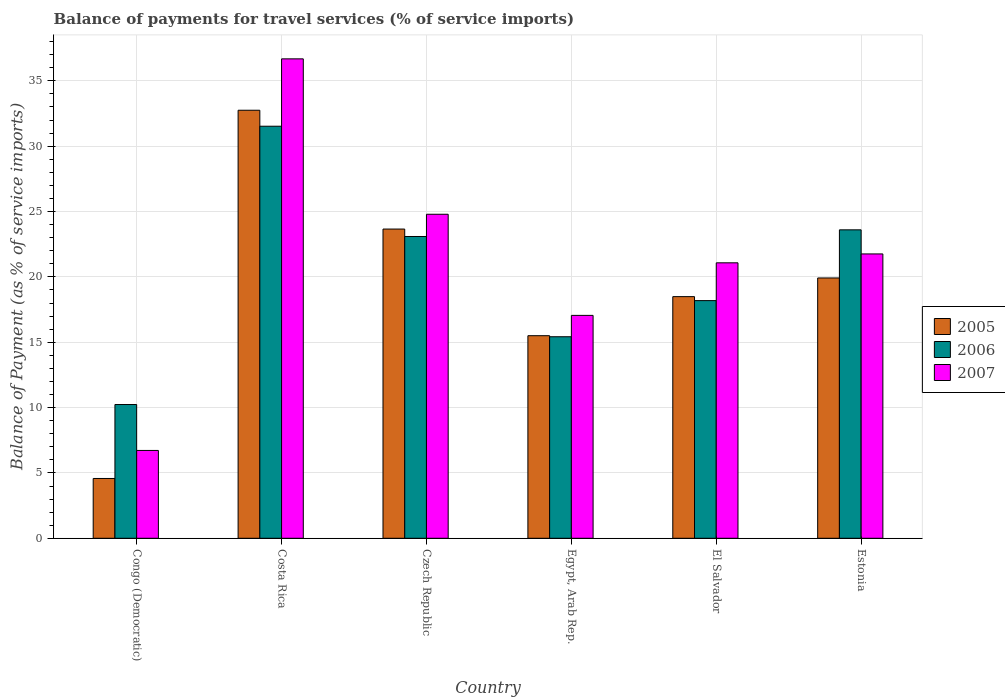How many different coloured bars are there?
Ensure brevity in your answer.  3. Are the number of bars on each tick of the X-axis equal?
Your answer should be compact. Yes. What is the label of the 6th group of bars from the left?
Give a very brief answer. Estonia. What is the balance of payments for travel services in 2005 in Costa Rica?
Provide a short and direct response. 32.75. Across all countries, what is the maximum balance of payments for travel services in 2006?
Keep it short and to the point. 31.53. Across all countries, what is the minimum balance of payments for travel services in 2006?
Make the answer very short. 10.23. In which country was the balance of payments for travel services in 2005 minimum?
Make the answer very short. Congo (Democratic). What is the total balance of payments for travel services in 2007 in the graph?
Provide a succinct answer. 128.08. What is the difference between the balance of payments for travel services in 2007 in Czech Republic and that in Estonia?
Ensure brevity in your answer.  3.03. What is the difference between the balance of payments for travel services in 2007 in Czech Republic and the balance of payments for travel services in 2005 in Estonia?
Your answer should be compact. 4.87. What is the average balance of payments for travel services in 2007 per country?
Offer a very short reply. 21.35. What is the difference between the balance of payments for travel services of/in 2005 and balance of payments for travel services of/in 2007 in El Salvador?
Give a very brief answer. -2.59. In how many countries, is the balance of payments for travel services in 2006 greater than 26 %?
Your answer should be very brief. 1. What is the ratio of the balance of payments for travel services in 2005 in Czech Republic to that in Egypt, Arab Rep.?
Your answer should be very brief. 1.53. Is the balance of payments for travel services in 2006 in Czech Republic less than that in El Salvador?
Your answer should be very brief. No. Is the difference between the balance of payments for travel services in 2005 in Czech Republic and Estonia greater than the difference between the balance of payments for travel services in 2007 in Czech Republic and Estonia?
Provide a short and direct response. Yes. What is the difference between the highest and the second highest balance of payments for travel services in 2006?
Offer a terse response. 0.51. What is the difference between the highest and the lowest balance of payments for travel services in 2006?
Offer a very short reply. 21.29. In how many countries, is the balance of payments for travel services in 2006 greater than the average balance of payments for travel services in 2006 taken over all countries?
Offer a very short reply. 3. Is the sum of the balance of payments for travel services in 2006 in El Salvador and Estonia greater than the maximum balance of payments for travel services in 2007 across all countries?
Your response must be concise. Yes. Is it the case that in every country, the sum of the balance of payments for travel services in 2006 and balance of payments for travel services in 2005 is greater than the balance of payments for travel services in 2007?
Give a very brief answer. Yes. How many bars are there?
Make the answer very short. 18. Are the values on the major ticks of Y-axis written in scientific E-notation?
Offer a terse response. No. Where does the legend appear in the graph?
Your response must be concise. Center right. What is the title of the graph?
Your response must be concise. Balance of payments for travel services (% of service imports). Does "1980" appear as one of the legend labels in the graph?
Provide a short and direct response. No. What is the label or title of the Y-axis?
Keep it short and to the point. Balance of Payment (as % of service imports). What is the Balance of Payment (as % of service imports) in 2005 in Congo (Democratic)?
Provide a succinct answer. 4.58. What is the Balance of Payment (as % of service imports) in 2006 in Congo (Democratic)?
Keep it short and to the point. 10.23. What is the Balance of Payment (as % of service imports) in 2007 in Congo (Democratic)?
Ensure brevity in your answer.  6.72. What is the Balance of Payment (as % of service imports) in 2005 in Costa Rica?
Provide a short and direct response. 32.75. What is the Balance of Payment (as % of service imports) of 2006 in Costa Rica?
Make the answer very short. 31.53. What is the Balance of Payment (as % of service imports) of 2007 in Costa Rica?
Your response must be concise. 36.68. What is the Balance of Payment (as % of service imports) of 2005 in Czech Republic?
Keep it short and to the point. 23.66. What is the Balance of Payment (as % of service imports) of 2006 in Czech Republic?
Keep it short and to the point. 23.09. What is the Balance of Payment (as % of service imports) in 2007 in Czech Republic?
Give a very brief answer. 24.79. What is the Balance of Payment (as % of service imports) of 2005 in Egypt, Arab Rep.?
Offer a very short reply. 15.5. What is the Balance of Payment (as % of service imports) of 2006 in Egypt, Arab Rep.?
Your response must be concise. 15.42. What is the Balance of Payment (as % of service imports) in 2007 in Egypt, Arab Rep.?
Ensure brevity in your answer.  17.05. What is the Balance of Payment (as % of service imports) in 2005 in El Salvador?
Offer a very short reply. 18.49. What is the Balance of Payment (as % of service imports) of 2006 in El Salvador?
Ensure brevity in your answer.  18.18. What is the Balance of Payment (as % of service imports) in 2007 in El Salvador?
Offer a very short reply. 21.08. What is the Balance of Payment (as % of service imports) in 2005 in Estonia?
Your answer should be compact. 19.92. What is the Balance of Payment (as % of service imports) in 2006 in Estonia?
Your response must be concise. 23.6. What is the Balance of Payment (as % of service imports) in 2007 in Estonia?
Keep it short and to the point. 21.76. Across all countries, what is the maximum Balance of Payment (as % of service imports) in 2005?
Make the answer very short. 32.75. Across all countries, what is the maximum Balance of Payment (as % of service imports) of 2006?
Ensure brevity in your answer.  31.53. Across all countries, what is the maximum Balance of Payment (as % of service imports) of 2007?
Provide a succinct answer. 36.68. Across all countries, what is the minimum Balance of Payment (as % of service imports) in 2005?
Make the answer very short. 4.58. Across all countries, what is the minimum Balance of Payment (as % of service imports) of 2006?
Provide a succinct answer. 10.23. Across all countries, what is the minimum Balance of Payment (as % of service imports) in 2007?
Offer a terse response. 6.72. What is the total Balance of Payment (as % of service imports) in 2005 in the graph?
Your response must be concise. 114.89. What is the total Balance of Payment (as % of service imports) of 2006 in the graph?
Make the answer very short. 122.05. What is the total Balance of Payment (as % of service imports) of 2007 in the graph?
Provide a short and direct response. 128.08. What is the difference between the Balance of Payment (as % of service imports) in 2005 in Congo (Democratic) and that in Costa Rica?
Your response must be concise. -28.17. What is the difference between the Balance of Payment (as % of service imports) of 2006 in Congo (Democratic) and that in Costa Rica?
Offer a terse response. -21.29. What is the difference between the Balance of Payment (as % of service imports) of 2007 in Congo (Democratic) and that in Costa Rica?
Provide a succinct answer. -29.96. What is the difference between the Balance of Payment (as % of service imports) in 2005 in Congo (Democratic) and that in Czech Republic?
Provide a short and direct response. -19.08. What is the difference between the Balance of Payment (as % of service imports) in 2006 in Congo (Democratic) and that in Czech Republic?
Offer a very short reply. -12.86. What is the difference between the Balance of Payment (as % of service imports) of 2007 in Congo (Democratic) and that in Czech Republic?
Provide a succinct answer. -18.07. What is the difference between the Balance of Payment (as % of service imports) of 2005 in Congo (Democratic) and that in Egypt, Arab Rep.?
Provide a short and direct response. -10.92. What is the difference between the Balance of Payment (as % of service imports) in 2006 in Congo (Democratic) and that in Egypt, Arab Rep.?
Give a very brief answer. -5.19. What is the difference between the Balance of Payment (as % of service imports) of 2007 in Congo (Democratic) and that in Egypt, Arab Rep.?
Make the answer very short. -10.33. What is the difference between the Balance of Payment (as % of service imports) in 2005 in Congo (Democratic) and that in El Salvador?
Provide a succinct answer. -13.91. What is the difference between the Balance of Payment (as % of service imports) of 2006 in Congo (Democratic) and that in El Salvador?
Your response must be concise. -7.95. What is the difference between the Balance of Payment (as % of service imports) in 2007 in Congo (Democratic) and that in El Salvador?
Your response must be concise. -14.36. What is the difference between the Balance of Payment (as % of service imports) in 2005 in Congo (Democratic) and that in Estonia?
Offer a very short reply. -15.34. What is the difference between the Balance of Payment (as % of service imports) of 2006 in Congo (Democratic) and that in Estonia?
Offer a very short reply. -13.37. What is the difference between the Balance of Payment (as % of service imports) in 2007 in Congo (Democratic) and that in Estonia?
Give a very brief answer. -15.04. What is the difference between the Balance of Payment (as % of service imports) of 2005 in Costa Rica and that in Czech Republic?
Your response must be concise. 9.09. What is the difference between the Balance of Payment (as % of service imports) of 2006 in Costa Rica and that in Czech Republic?
Your answer should be compact. 8.44. What is the difference between the Balance of Payment (as % of service imports) in 2007 in Costa Rica and that in Czech Republic?
Give a very brief answer. 11.89. What is the difference between the Balance of Payment (as % of service imports) of 2005 in Costa Rica and that in Egypt, Arab Rep.?
Ensure brevity in your answer.  17.25. What is the difference between the Balance of Payment (as % of service imports) of 2006 in Costa Rica and that in Egypt, Arab Rep.?
Give a very brief answer. 16.11. What is the difference between the Balance of Payment (as % of service imports) in 2007 in Costa Rica and that in Egypt, Arab Rep.?
Your response must be concise. 19.63. What is the difference between the Balance of Payment (as % of service imports) of 2005 in Costa Rica and that in El Salvador?
Offer a terse response. 14.26. What is the difference between the Balance of Payment (as % of service imports) of 2006 in Costa Rica and that in El Salvador?
Offer a very short reply. 13.34. What is the difference between the Balance of Payment (as % of service imports) of 2007 in Costa Rica and that in El Salvador?
Your answer should be compact. 15.61. What is the difference between the Balance of Payment (as % of service imports) of 2005 in Costa Rica and that in Estonia?
Keep it short and to the point. 12.83. What is the difference between the Balance of Payment (as % of service imports) of 2006 in Costa Rica and that in Estonia?
Keep it short and to the point. 7.93. What is the difference between the Balance of Payment (as % of service imports) in 2007 in Costa Rica and that in Estonia?
Offer a very short reply. 14.93. What is the difference between the Balance of Payment (as % of service imports) of 2005 in Czech Republic and that in Egypt, Arab Rep.?
Ensure brevity in your answer.  8.16. What is the difference between the Balance of Payment (as % of service imports) of 2006 in Czech Republic and that in Egypt, Arab Rep.?
Your answer should be compact. 7.67. What is the difference between the Balance of Payment (as % of service imports) in 2007 in Czech Republic and that in Egypt, Arab Rep.?
Offer a terse response. 7.74. What is the difference between the Balance of Payment (as % of service imports) of 2005 in Czech Republic and that in El Salvador?
Your response must be concise. 5.17. What is the difference between the Balance of Payment (as % of service imports) in 2006 in Czech Republic and that in El Salvador?
Make the answer very short. 4.91. What is the difference between the Balance of Payment (as % of service imports) in 2007 in Czech Republic and that in El Salvador?
Your answer should be very brief. 3.72. What is the difference between the Balance of Payment (as % of service imports) of 2005 in Czech Republic and that in Estonia?
Offer a terse response. 3.74. What is the difference between the Balance of Payment (as % of service imports) of 2006 in Czech Republic and that in Estonia?
Make the answer very short. -0.51. What is the difference between the Balance of Payment (as % of service imports) in 2007 in Czech Republic and that in Estonia?
Your response must be concise. 3.04. What is the difference between the Balance of Payment (as % of service imports) of 2005 in Egypt, Arab Rep. and that in El Salvador?
Provide a short and direct response. -2.99. What is the difference between the Balance of Payment (as % of service imports) in 2006 in Egypt, Arab Rep. and that in El Salvador?
Your response must be concise. -2.76. What is the difference between the Balance of Payment (as % of service imports) in 2007 in Egypt, Arab Rep. and that in El Salvador?
Make the answer very short. -4.02. What is the difference between the Balance of Payment (as % of service imports) in 2005 in Egypt, Arab Rep. and that in Estonia?
Provide a succinct answer. -4.42. What is the difference between the Balance of Payment (as % of service imports) in 2006 in Egypt, Arab Rep. and that in Estonia?
Your answer should be compact. -8.18. What is the difference between the Balance of Payment (as % of service imports) of 2007 in Egypt, Arab Rep. and that in Estonia?
Offer a terse response. -4.7. What is the difference between the Balance of Payment (as % of service imports) of 2005 in El Salvador and that in Estonia?
Your response must be concise. -1.43. What is the difference between the Balance of Payment (as % of service imports) in 2006 in El Salvador and that in Estonia?
Make the answer very short. -5.42. What is the difference between the Balance of Payment (as % of service imports) of 2007 in El Salvador and that in Estonia?
Your answer should be very brief. -0.68. What is the difference between the Balance of Payment (as % of service imports) in 2005 in Congo (Democratic) and the Balance of Payment (as % of service imports) in 2006 in Costa Rica?
Your response must be concise. -26.95. What is the difference between the Balance of Payment (as % of service imports) of 2005 in Congo (Democratic) and the Balance of Payment (as % of service imports) of 2007 in Costa Rica?
Ensure brevity in your answer.  -32.11. What is the difference between the Balance of Payment (as % of service imports) of 2006 in Congo (Democratic) and the Balance of Payment (as % of service imports) of 2007 in Costa Rica?
Provide a short and direct response. -26.45. What is the difference between the Balance of Payment (as % of service imports) in 2005 in Congo (Democratic) and the Balance of Payment (as % of service imports) in 2006 in Czech Republic?
Make the answer very short. -18.51. What is the difference between the Balance of Payment (as % of service imports) of 2005 in Congo (Democratic) and the Balance of Payment (as % of service imports) of 2007 in Czech Republic?
Give a very brief answer. -20.22. What is the difference between the Balance of Payment (as % of service imports) of 2006 in Congo (Democratic) and the Balance of Payment (as % of service imports) of 2007 in Czech Republic?
Keep it short and to the point. -14.56. What is the difference between the Balance of Payment (as % of service imports) of 2005 in Congo (Democratic) and the Balance of Payment (as % of service imports) of 2006 in Egypt, Arab Rep.?
Keep it short and to the point. -10.84. What is the difference between the Balance of Payment (as % of service imports) of 2005 in Congo (Democratic) and the Balance of Payment (as % of service imports) of 2007 in Egypt, Arab Rep.?
Provide a short and direct response. -12.48. What is the difference between the Balance of Payment (as % of service imports) of 2006 in Congo (Democratic) and the Balance of Payment (as % of service imports) of 2007 in Egypt, Arab Rep.?
Offer a very short reply. -6.82. What is the difference between the Balance of Payment (as % of service imports) in 2005 in Congo (Democratic) and the Balance of Payment (as % of service imports) in 2006 in El Salvador?
Offer a terse response. -13.61. What is the difference between the Balance of Payment (as % of service imports) of 2005 in Congo (Democratic) and the Balance of Payment (as % of service imports) of 2007 in El Salvador?
Provide a succinct answer. -16.5. What is the difference between the Balance of Payment (as % of service imports) in 2006 in Congo (Democratic) and the Balance of Payment (as % of service imports) in 2007 in El Salvador?
Provide a succinct answer. -10.84. What is the difference between the Balance of Payment (as % of service imports) of 2005 in Congo (Democratic) and the Balance of Payment (as % of service imports) of 2006 in Estonia?
Provide a succinct answer. -19.02. What is the difference between the Balance of Payment (as % of service imports) of 2005 in Congo (Democratic) and the Balance of Payment (as % of service imports) of 2007 in Estonia?
Make the answer very short. -17.18. What is the difference between the Balance of Payment (as % of service imports) of 2006 in Congo (Democratic) and the Balance of Payment (as % of service imports) of 2007 in Estonia?
Your response must be concise. -11.52. What is the difference between the Balance of Payment (as % of service imports) of 2005 in Costa Rica and the Balance of Payment (as % of service imports) of 2006 in Czech Republic?
Give a very brief answer. 9.66. What is the difference between the Balance of Payment (as % of service imports) in 2005 in Costa Rica and the Balance of Payment (as % of service imports) in 2007 in Czech Republic?
Provide a short and direct response. 7.96. What is the difference between the Balance of Payment (as % of service imports) of 2006 in Costa Rica and the Balance of Payment (as % of service imports) of 2007 in Czech Republic?
Give a very brief answer. 6.74. What is the difference between the Balance of Payment (as % of service imports) of 2005 in Costa Rica and the Balance of Payment (as % of service imports) of 2006 in Egypt, Arab Rep.?
Your answer should be very brief. 17.33. What is the difference between the Balance of Payment (as % of service imports) in 2005 in Costa Rica and the Balance of Payment (as % of service imports) in 2007 in Egypt, Arab Rep.?
Provide a short and direct response. 15.7. What is the difference between the Balance of Payment (as % of service imports) in 2006 in Costa Rica and the Balance of Payment (as % of service imports) in 2007 in Egypt, Arab Rep.?
Provide a short and direct response. 14.47. What is the difference between the Balance of Payment (as % of service imports) of 2005 in Costa Rica and the Balance of Payment (as % of service imports) of 2006 in El Salvador?
Your answer should be compact. 14.57. What is the difference between the Balance of Payment (as % of service imports) of 2005 in Costa Rica and the Balance of Payment (as % of service imports) of 2007 in El Salvador?
Offer a terse response. 11.67. What is the difference between the Balance of Payment (as % of service imports) in 2006 in Costa Rica and the Balance of Payment (as % of service imports) in 2007 in El Salvador?
Your answer should be very brief. 10.45. What is the difference between the Balance of Payment (as % of service imports) in 2005 in Costa Rica and the Balance of Payment (as % of service imports) in 2006 in Estonia?
Your answer should be compact. 9.15. What is the difference between the Balance of Payment (as % of service imports) in 2005 in Costa Rica and the Balance of Payment (as % of service imports) in 2007 in Estonia?
Offer a terse response. 10.99. What is the difference between the Balance of Payment (as % of service imports) in 2006 in Costa Rica and the Balance of Payment (as % of service imports) in 2007 in Estonia?
Offer a terse response. 9.77. What is the difference between the Balance of Payment (as % of service imports) of 2005 in Czech Republic and the Balance of Payment (as % of service imports) of 2006 in Egypt, Arab Rep.?
Give a very brief answer. 8.24. What is the difference between the Balance of Payment (as % of service imports) of 2005 in Czech Republic and the Balance of Payment (as % of service imports) of 2007 in Egypt, Arab Rep.?
Ensure brevity in your answer.  6.61. What is the difference between the Balance of Payment (as % of service imports) of 2006 in Czech Republic and the Balance of Payment (as % of service imports) of 2007 in Egypt, Arab Rep.?
Your answer should be very brief. 6.04. What is the difference between the Balance of Payment (as % of service imports) in 2005 in Czech Republic and the Balance of Payment (as % of service imports) in 2006 in El Salvador?
Keep it short and to the point. 5.48. What is the difference between the Balance of Payment (as % of service imports) in 2005 in Czech Republic and the Balance of Payment (as % of service imports) in 2007 in El Salvador?
Keep it short and to the point. 2.58. What is the difference between the Balance of Payment (as % of service imports) in 2006 in Czech Republic and the Balance of Payment (as % of service imports) in 2007 in El Salvador?
Provide a succinct answer. 2.02. What is the difference between the Balance of Payment (as % of service imports) in 2005 in Czech Republic and the Balance of Payment (as % of service imports) in 2006 in Estonia?
Offer a terse response. 0.06. What is the difference between the Balance of Payment (as % of service imports) in 2005 in Czech Republic and the Balance of Payment (as % of service imports) in 2007 in Estonia?
Offer a terse response. 1.9. What is the difference between the Balance of Payment (as % of service imports) of 2006 in Czech Republic and the Balance of Payment (as % of service imports) of 2007 in Estonia?
Offer a terse response. 1.33. What is the difference between the Balance of Payment (as % of service imports) of 2005 in Egypt, Arab Rep. and the Balance of Payment (as % of service imports) of 2006 in El Salvador?
Offer a terse response. -2.68. What is the difference between the Balance of Payment (as % of service imports) in 2005 in Egypt, Arab Rep. and the Balance of Payment (as % of service imports) in 2007 in El Salvador?
Make the answer very short. -5.58. What is the difference between the Balance of Payment (as % of service imports) in 2006 in Egypt, Arab Rep. and the Balance of Payment (as % of service imports) in 2007 in El Salvador?
Give a very brief answer. -5.66. What is the difference between the Balance of Payment (as % of service imports) in 2005 in Egypt, Arab Rep. and the Balance of Payment (as % of service imports) in 2006 in Estonia?
Keep it short and to the point. -8.1. What is the difference between the Balance of Payment (as % of service imports) of 2005 in Egypt, Arab Rep. and the Balance of Payment (as % of service imports) of 2007 in Estonia?
Give a very brief answer. -6.26. What is the difference between the Balance of Payment (as % of service imports) in 2006 in Egypt, Arab Rep. and the Balance of Payment (as % of service imports) in 2007 in Estonia?
Your answer should be very brief. -6.34. What is the difference between the Balance of Payment (as % of service imports) of 2005 in El Salvador and the Balance of Payment (as % of service imports) of 2006 in Estonia?
Your answer should be very brief. -5.11. What is the difference between the Balance of Payment (as % of service imports) of 2005 in El Salvador and the Balance of Payment (as % of service imports) of 2007 in Estonia?
Make the answer very short. -3.27. What is the difference between the Balance of Payment (as % of service imports) of 2006 in El Salvador and the Balance of Payment (as % of service imports) of 2007 in Estonia?
Ensure brevity in your answer.  -3.57. What is the average Balance of Payment (as % of service imports) of 2005 per country?
Ensure brevity in your answer.  19.15. What is the average Balance of Payment (as % of service imports) in 2006 per country?
Make the answer very short. 20.34. What is the average Balance of Payment (as % of service imports) of 2007 per country?
Ensure brevity in your answer.  21.35. What is the difference between the Balance of Payment (as % of service imports) of 2005 and Balance of Payment (as % of service imports) of 2006 in Congo (Democratic)?
Keep it short and to the point. -5.66. What is the difference between the Balance of Payment (as % of service imports) of 2005 and Balance of Payment (as % of service imports) of 2007 in Congo (Democratic)?
Offer a very short reply. -2.14. What is the difference between the Balance of Payment (as % of service imports) of 2006 and Balance of Payment (as % of service imports) of 2007 in Congo (Democratic)?
Make the answer very short. 3.51. What is the difference between the Balance of Payment (as % of service imports) of 2005 and Balance of Payment (as % of service imports) of 2006 in Costa Rica?
Your answer should be very brief. 1.22. What is the difference between the Balance of Payment (as % of service imports) of 2005 and Balance of Payment (as % of service imports) of 2007 in Costa Rica?
Offer a very short reply. -3.93. What is the difference between the Balance of Payment (as % of service imports) of 2006 and Balance of Payment (as % of service imports) of 2007 in Costa Rica?
Provide a short and direct response. -5.15. What is the difference between the Balance of Payment (as % of service imports) of 2005 and Balance of Payment (as % of service imports) of 2006 in Czech Republic?
Keep it short and to the point. 0.57. What is the difference between the Balance of Payment (as % of service imports) in 2005 and Balance of Payment (as % of service imports) in 2007 in Czech Republic?
Keep it short and to the point. -1.13. What is the difference between the Balance of Payment (as % of service imports) in 2006 and Balance of Payment (as % of service imports) in 2007 in Czech Republic?
Your answer should be very brief. -1.7. What is the difference between the Balance of Payment (as % of service imports) of 2005 and Balance of Payment (as % of service imports) of 2006 in Egypt, Arab Rep.?
Your answer should be compact. 0.08. What is the difference between the Balance of Payment (as % of service imports) of 2005 and Balance of Payment (as % of service imports) of 2007 in Egypt, Arab Rep.?
Your answer should be compact. -1.55. What is the difference between the Balance of Payment (as % of service imports) of 2006 and Balance of Payment (as % of service imports) of 2007 in Egypt, Arab Rep.?
Your answer should be compact. -1.63. What is the difference between the Balance of Payment (as % of service imports) in 2005 and Balance of Payment (as % of service imports) in 2006 in El Salvador?
Offer a very short reply. 0.31. What is the difference between the Balance of Payment (as % of service imports) in 2005 and Balance of Payment (as % of service imports) in 2007 in El Salvador?
Offer a terse response. -2.59. What is the difference between the Balance of Payment (as % of service imports) of 2006 and Balance of Payment (as % of service imports) of 2007 in El Salvador?
Give a very brief answer. -2.89. What is the difference between the Balance of Payment (as % of service imports) in 2005 and Balance of Payment (as % of service imports) in 2006 in Estonia?
Ensure brevity in your answer.  -3.68. What is the difference between the Balance of Payment (as % of service imports) of 2005 and Balance of Payment (as % of service imports) of 2007 in Estonia?
Provide a succinct answer. -1.84. What is the difference between the Balance of Payment (as % of service imports) of 2006 and Balance of Payment (as % of service imports) of 2007 in Estonia?
Your answer should be very brief. 1.84. What is the ratio of the Balance of Payment (as % of service imports) of 2005 in Congo (Democratic) to that in Costa Rica?
Your answer should be compact. 0.14. What is the ratio of the Balance of Payment (as % of service imports) in 2006 in Congo (Democratic) to that in Costa Rica?
Offer a very short reply. 0.32. What is the ratio of the Balance of Payment (as % of service imports) in 2007 in Congo (Democratic) to that in Costa Rica?
Your answer should be compact. 0.18. What is the ratio of the Balance of Payment (as % of service imports) in 2005 in Congo (Democratic) to that in Czech Republic?
Your response must be concise. 0.19. What is the ratio of the Balance of Payment (as % of service imports) in 2006 in Congo (Democratic) to that in Czech Republic?
Your response must be concise. 0.44. What is the ratio of the Balance of Payment (as % of service imports) of 2007 in Congo (Democratic) to that in Czech Republic?
Your response must be concise. 0.27. What is the ratio of the Balance of Payment (as % of service imports) of 2005 in Congo (Democratic) to that in Egypt, Arab Rep.?
Ensure brevity in your answer.  0.3. What is the ratio of the Balance of Payment (as % of service imports) in 2006 in Congo (Democratic) to that in Egypt, Arab Rep.?
Your answer should be compact. 0.66. What is the ratio of the Balance of Payment (as % of service imports) in 2007 in Congo (Democratic) to that in Egypt, Arab Rep.?
Your response must be concise. 0.39. What is the ratio of the Balance of Payment (as % of service imports) in 2005 in Congo (Democratic) to that in El Salvador?
Make the answer very short. 0.25. What is the ratio of the Balance of Payment (as % of service imports) of 2006 in Congo (Democratic) to that in El Salvador?
Offer a terse response. 0.56. What is the ratio of the Balance of Payment (as % of service imports) in 2007 in Congo (Democratic) to that in El Salvador?
Keep it short and to the point. 0.32. What is the ratio of the Balance of Payment (as % of service imports) of 2005 in Congo (Democratic) to that in Estonia?
Provide a succinct answer. 0.23. What is the ratio of the Balance of Payment (as % of service imports) in 2006 in Congo (Democratic) to that in Estonia?
Offer a terse response. 0.43. What is the ratio of the Balance of Payment (as % of service imports) in 2007 in Congo (Democratic) to that in Estonia?
Your answer should be compact. 0.31. What is the ratio of the Balance of Payment (as % of service imports) in 2005 in Costa Rica to that in Czech Republic?
Make the answer very short. 1.38. What is the ratio of the Balance of Payment (as % of service imports) of 2006 in Costa Rica to that in Czech Republic?
Offer a very short reply. 1.37. What is the ratio of the Balance of Payment (as % of service imports) in 2007 in Costa Rica to that in Czech Republic?
Give a very brief answer. 1.48. What is the ratio of the Balance of Payment (as % of service imports) of 2005 in Costa Rica to that in Egypt, Arab Rep.?
Give a very brief answer. 2.11. What is the ratio of the Balance of Payment (as % of service imports) of 2006 in Costa Rica to that in Egypt, Arab Rep.?
Provide a succinct answer. 2.04. What is the ratio of the Balance of Payment (as % of service imports) of 2007 in Costa Rica to that in Egypt, Arab Rep.?
Keep it short and to the point. 2.15. What is the ratio of the Balance of Payment (as % of service imports) of 2005 in Costa Rica to that in El Salvador?
Provide a succinct answer. 1.77. What is the ratio of the Balance of Payment (as % of service imports) in 2006 in Costa Rica to that in El Salvador?
Keep it short and to the point. 1.73. What is the ratio of the Balance of Payment (as % of service imports) of 2007 in Costa Rica to that in El Salvador?
Offer a terse response. 1.74. What is the ratio of the Balance of Payment (as % of service imports) of 2005 in Costa Rica to that in Estonia?
Provide a succinct answer. 1.64. What is the ratio of the Balance of Payment (as % of service imports) in 2006 in Costa Rica to that in Estonia?
Your answer should be very brief. 1.34. What is the ratio of the Balance of Payment (as % of service imports) in 2007 in Costa Rica to that in Estonia?
Provide a succinct answer. 1.69. What is the ratio of the Balance of Payment (as % of service imports) in 2005 in Czech Republic to that in Egypt, Arab Rep.?
Ensure brevity in your answer.  1.53. What is the ratio of the Balance of Payment (as % of service imports) in 2006 in Czech Republic to that in Egypt, Arab Rep.?
Offer a terse response. 1.5. What is the ratio of the Balance of Payment (as % of service imports) of 2007 in Czech Republic to that in Egypt, Arab Rep.?
Your response must be concise. 1.45. What is the ratio of the Balance of Payment (as % of service imports) in 2005 in Czech Republic to that in El Salvador?
Offer a terse response. 1.28. What is the ratio of the Balance of Payment (as % of service imports) of 2006 in Czech Republic to that in El Salvador?
Keep it short and to the point. 1.27. What is the ratio of the Balance of Payment (as % of service imports) of 2007 in Czech Republic to that in El Salvador?
Provide a short and direct response. 1.18. What is the ratio of the Balance of Payment (as % of service imports) of 2005 in Czech Republic to that in Estonia?
Your response must be concise. 1.19. What is the ratio of the Balance of Payment (as % of service imports) in 2006 in Czech Republic to that in Estonia?
Keep it short and to the point. 0.98. What is the ratio of the Balance of Payment (as % of service imports) in 2007 in Czech Republic to that in Estonia?
Offer a very short reply. 1.14. What is the ratio of the Balance of Payment (as % of service imports) of 2005 in Egypt, Arab Rep. to that in El Salvador?
Your answer should be very brief. 0.84. What is the ratio of the Balance of Payment (as % of service imports) of 2006 in Egypt, Arab Rep. to that in El Salvador?
Your answer should be compact. 0.85. What is the ratio of the Balance of Payment (as % of service imports) of 2007 in Egypt, Arab Rep. to that in El Salvador?
Give a very brief answer. 0.81. What is the ratio of the Balance of Payment (as % of service imports) of 2005 in Egypt, Arab Rep. to that in Estonia?
Provide a succinct answer. 0.78. What is the ratio of the Balance of Payment (as % of service imports) of 2006 in Egypt, Arab Rep. to that in Estonia?
Provide a succinct answer. 0.65. What is the ratio of the Balance of Payment (as % of service imports) of 2007 in Egypt, Arab Rep. to that in Estonia?
Ensure brevity in your answer.  0.78. What is the ratio of the Balance of Payment (as % of service imports) of 2005 in El Salvador to that in Estonia?
Provide a short and direct response. 0.93. What is the ratio of the Balance of Payment (as % of service imports) of 2006 in El Salvador to that in Estonia?
Ensure brevity in your answer.  0.77. What is the ratio of the Balance of Payment (as % of service imports) in 2007 in El Salvador to that in Estonia?
Provide a short and direct response. 0.97. What is the difference between the highest and the second highest Balance of Payment (as % of service imports) in 2005?
Offer a terse response. 9.09. What is the difference between the highest and the second highest Balance of Payment (as % of service imports) in 2006?
Give a very brief answer. 7.93. What is the difference between the highest and the second highest Balance of Payment (as % of service imports) of 2007?
Provide a succinct answer. 11.89. What is the difference between the highest and the lowest Balance of Payment (as % of service imports) in 2005?
Offer a terse response. 28.17. What is the difference between the highest and the lowest Balance of Payment (as % of service imports) of 2006?
Your response must be concise. 21.29. What is the difference between the highest and the lowest Balance of Payment (as % of service imports) of 2007?
Your answer should be compact. 29.96. 